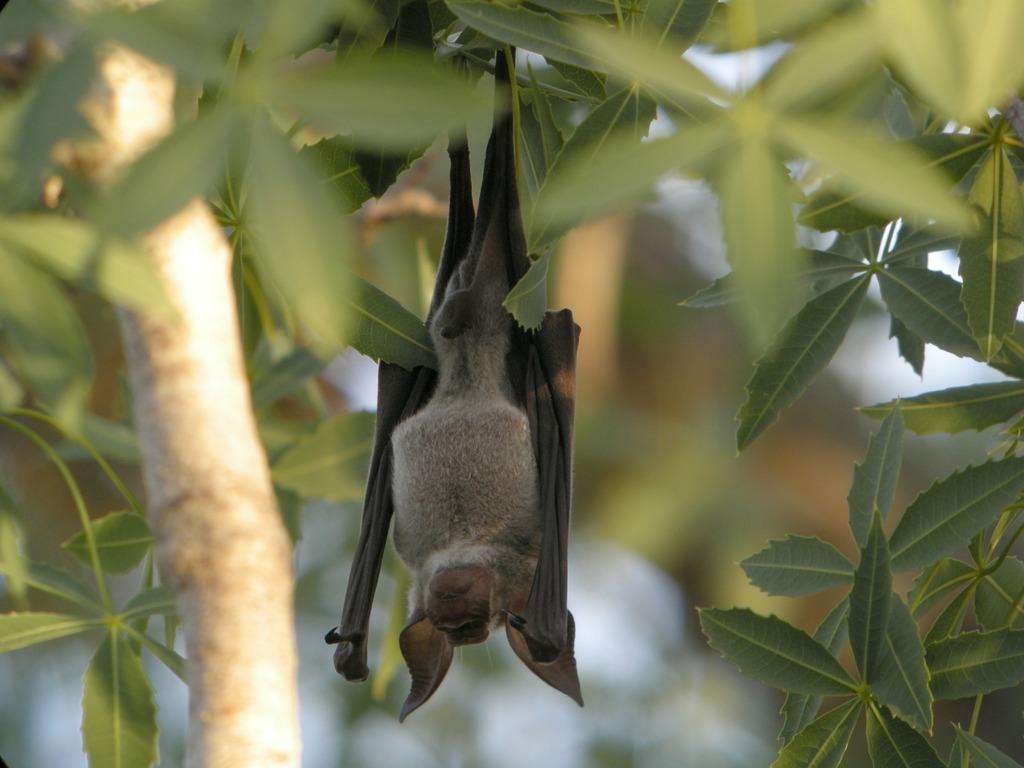What animal is hanging on the tree in the image? There is a bat hanging on a tree in the image. What features does the tree have? The tree has branches and leaves. How many ears can be seen on the leaves in the image? There are no ears present on the leaves in the image; leaves do not have ears. 